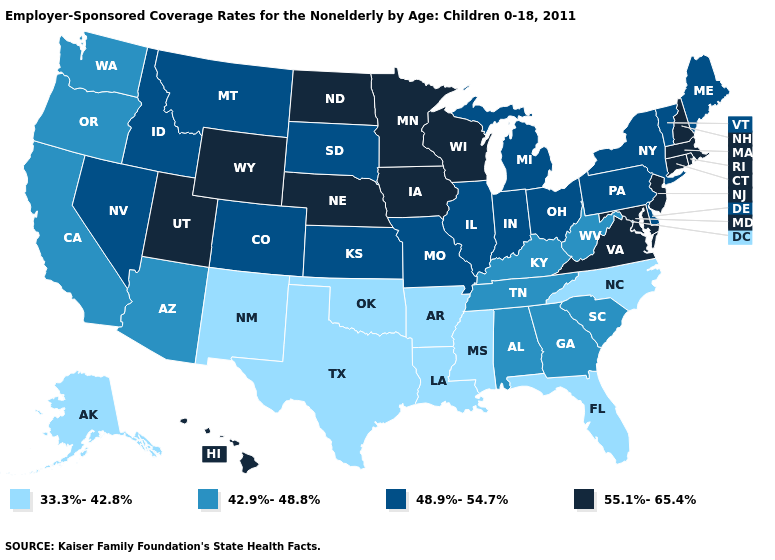Among the states that border Arkansas , which have the lowest value?
Give a very brief answer. Louisiana, Mississippi, Oklahoma, Texas. What is the value of Mississippi?
Concise answer only. 33.3%-42.8%. Does the map have missing data?
Write a very short answer. No. What is the lowest value in states that border Vermont?
Write a very short answer. 48.9%-54.7%. What is the value of California?
Quick response, please. 42.9%-48.8%. Among the states that border New Jersey , which have the highest value?
Be succinct. Delaware, New York, Pennsylvania. Does South Carolina have the highest value in the USA?
Answer briefly. No. What is the highest value in the USA?
Keep it brief. 55.1%-65.4%. Among the states that border Pennsylvania , does Maryland have the lowest value?
Concise answer only. No. What is the highest value in states that border Montana?
Short answer required. 55.1%-65.4%. What is the value of Nebraska?
Write a very short answer. 55.1%-65.4%. Is the legend a continuous bar?
Short answer required. No. What is the value of Indiana?
Quick response, please. 48.9%-54.7%. What is the lowest value in the USA?
Answer briefly. 33.3%-42.8%. What is the value of South Dakota?
Answer briefly. 48.9%-54.7%. 